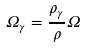<formula> <loc_0><loc_0><loc_500><loc_500>\Omega _ { \gamma } = \frac { \rho _ { \gamma } } { \rho } \Omega</formula> 